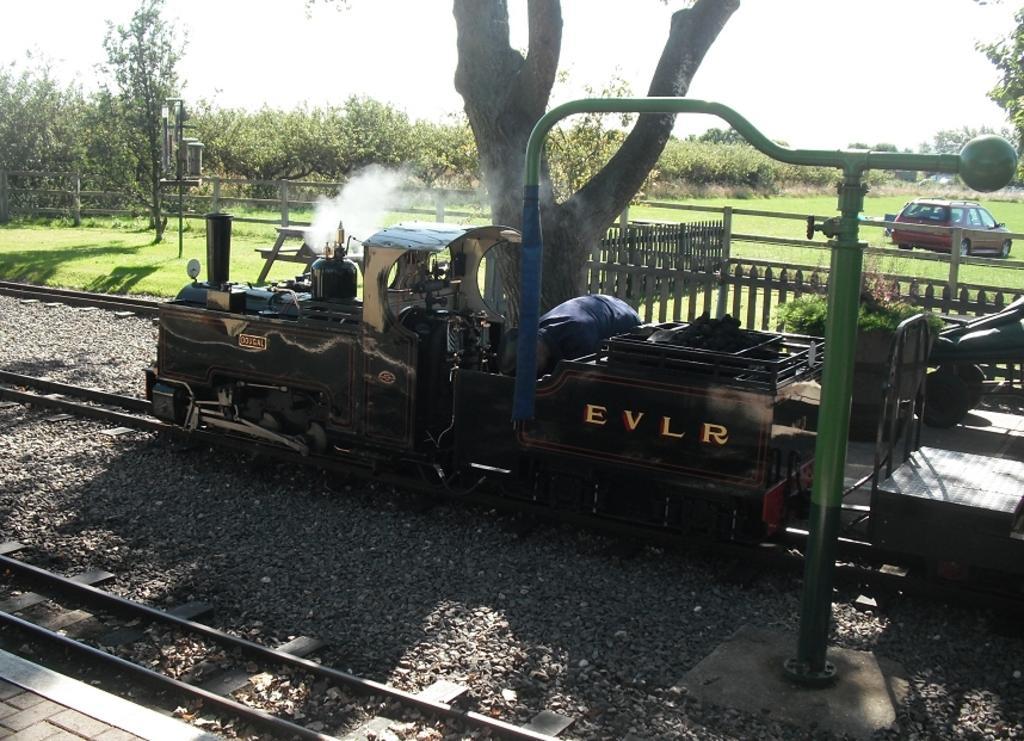Describe this image in one or two sentences. In this image, in the middle, we can see a train moving on the railway track. On the right side, we can see a metal rod and a car moving in the grass. On the left side, we can see a wood grill, pole, trees. In the background, we can see a wooden trunk, trees. At the top, we can see a sky, at the bottom, we can see a grass and some stones on the railway track. 